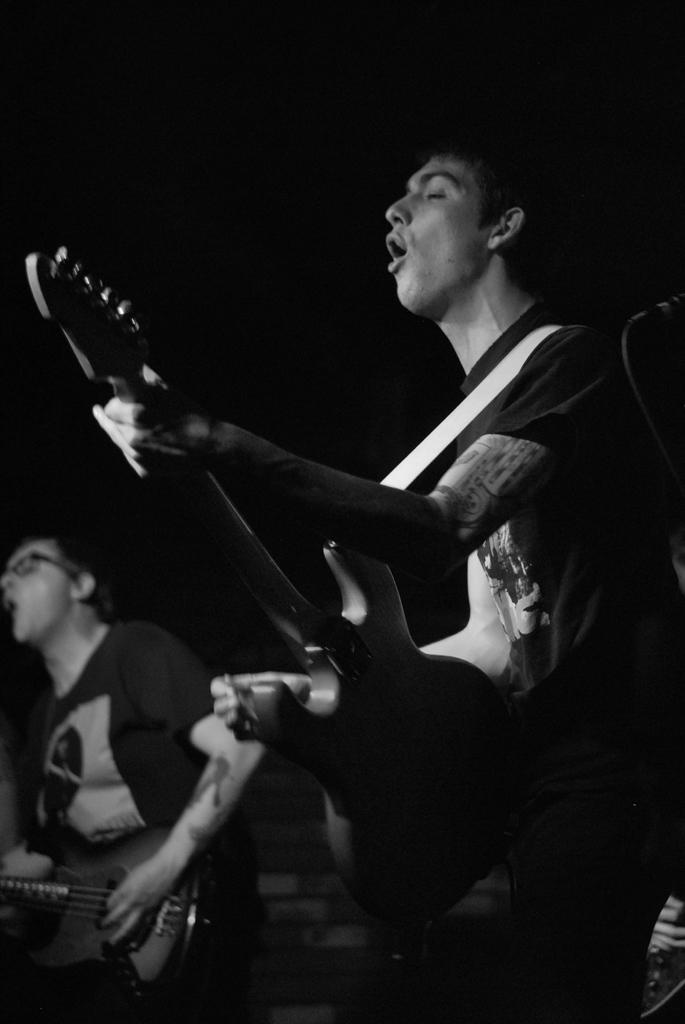Who is the main subject in the image? There is a man in the image. What is the man holding in the image? The man is holding a guitar. What is the man doing with the guitar? The man is playing the guitar. Are there any other people in the image? Yes, there is another person in the image. What is the other person holding? The other person is holding a guitar. What type of car can be seen in the background of the image? There is no car present in the image; it features two people playing guitars. 